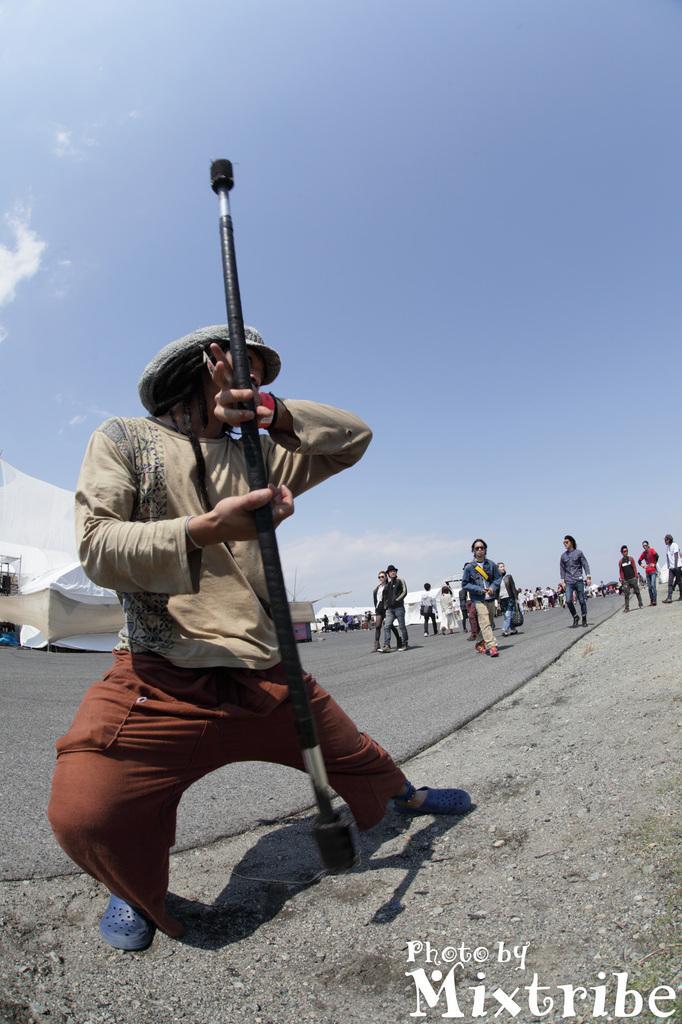Could you give a brief overview of what you see in this image? In the center of the image, we can see a person wearing a cap and holding a stick. In the background, there are many people and we can see some tents. At the bottom, there is a road and ground and we can see some text. 